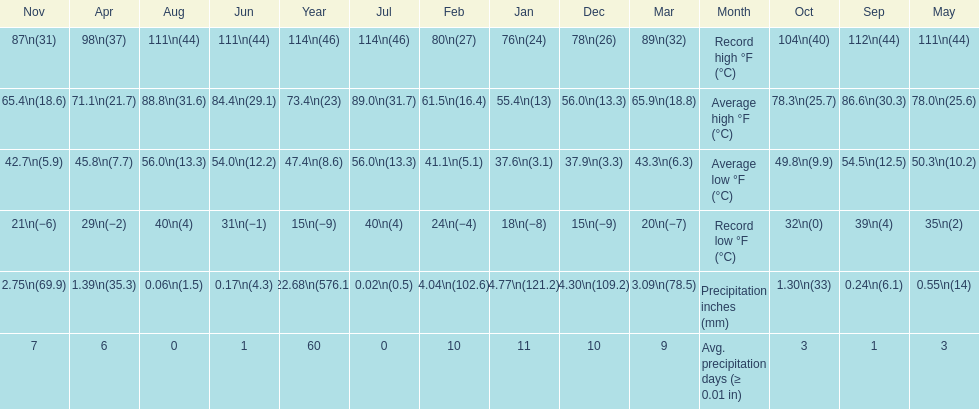Which month had an average high of 89.0 degrees and an average low of 56.0 degrees? July. 